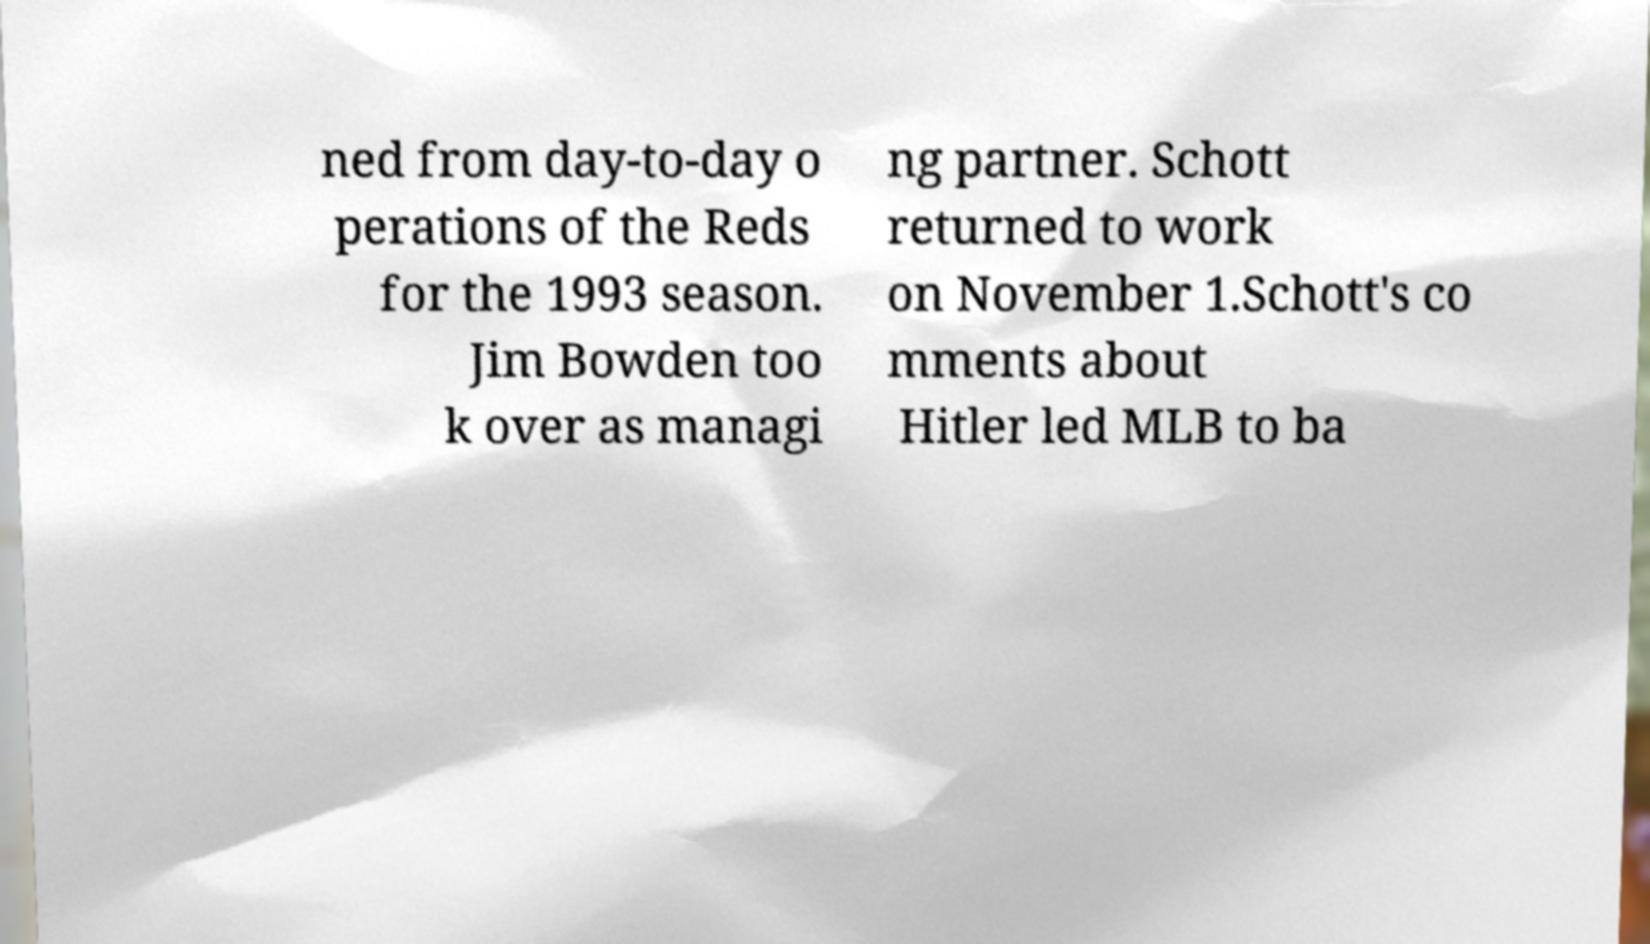Can you accurately transcribe the text from the provided image for me? ned from day-to-day o perations of the Reds for the 1993 season. Jim Bowden too k over as managi ng partner. Schott returned to work on November 1.Schott's co mments about Hitler led MLB to ba 